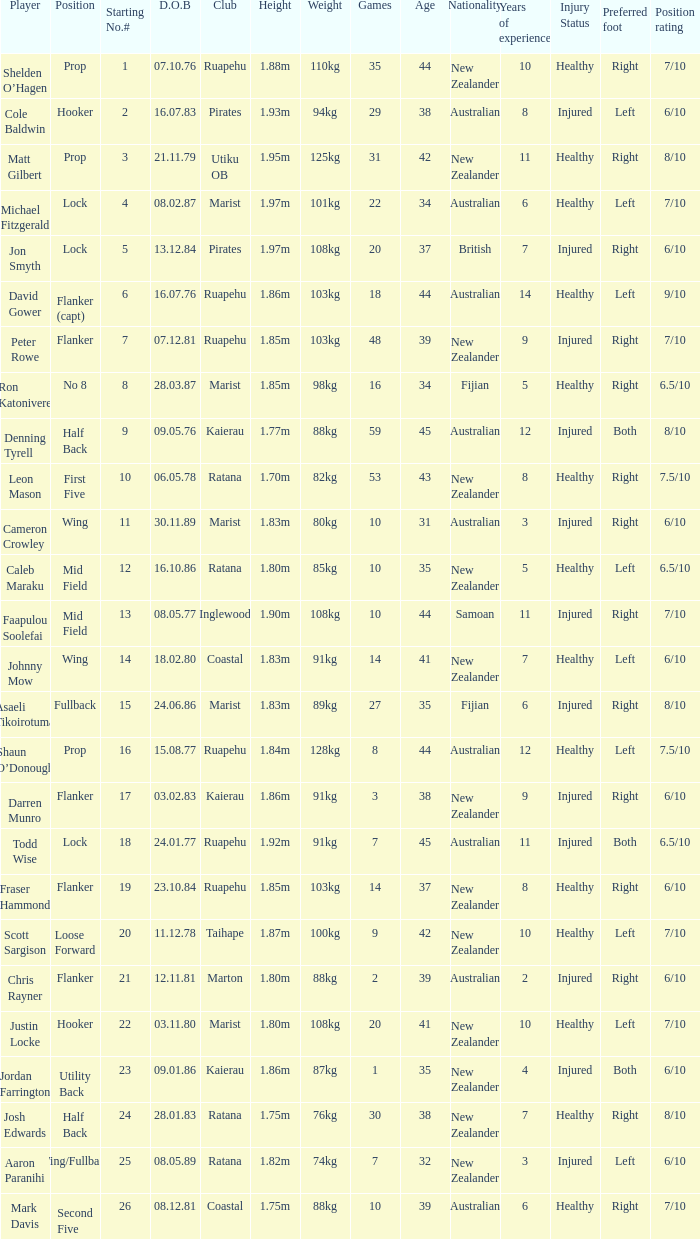How many games were played where the height of the player is 1.92m? 1.0. 